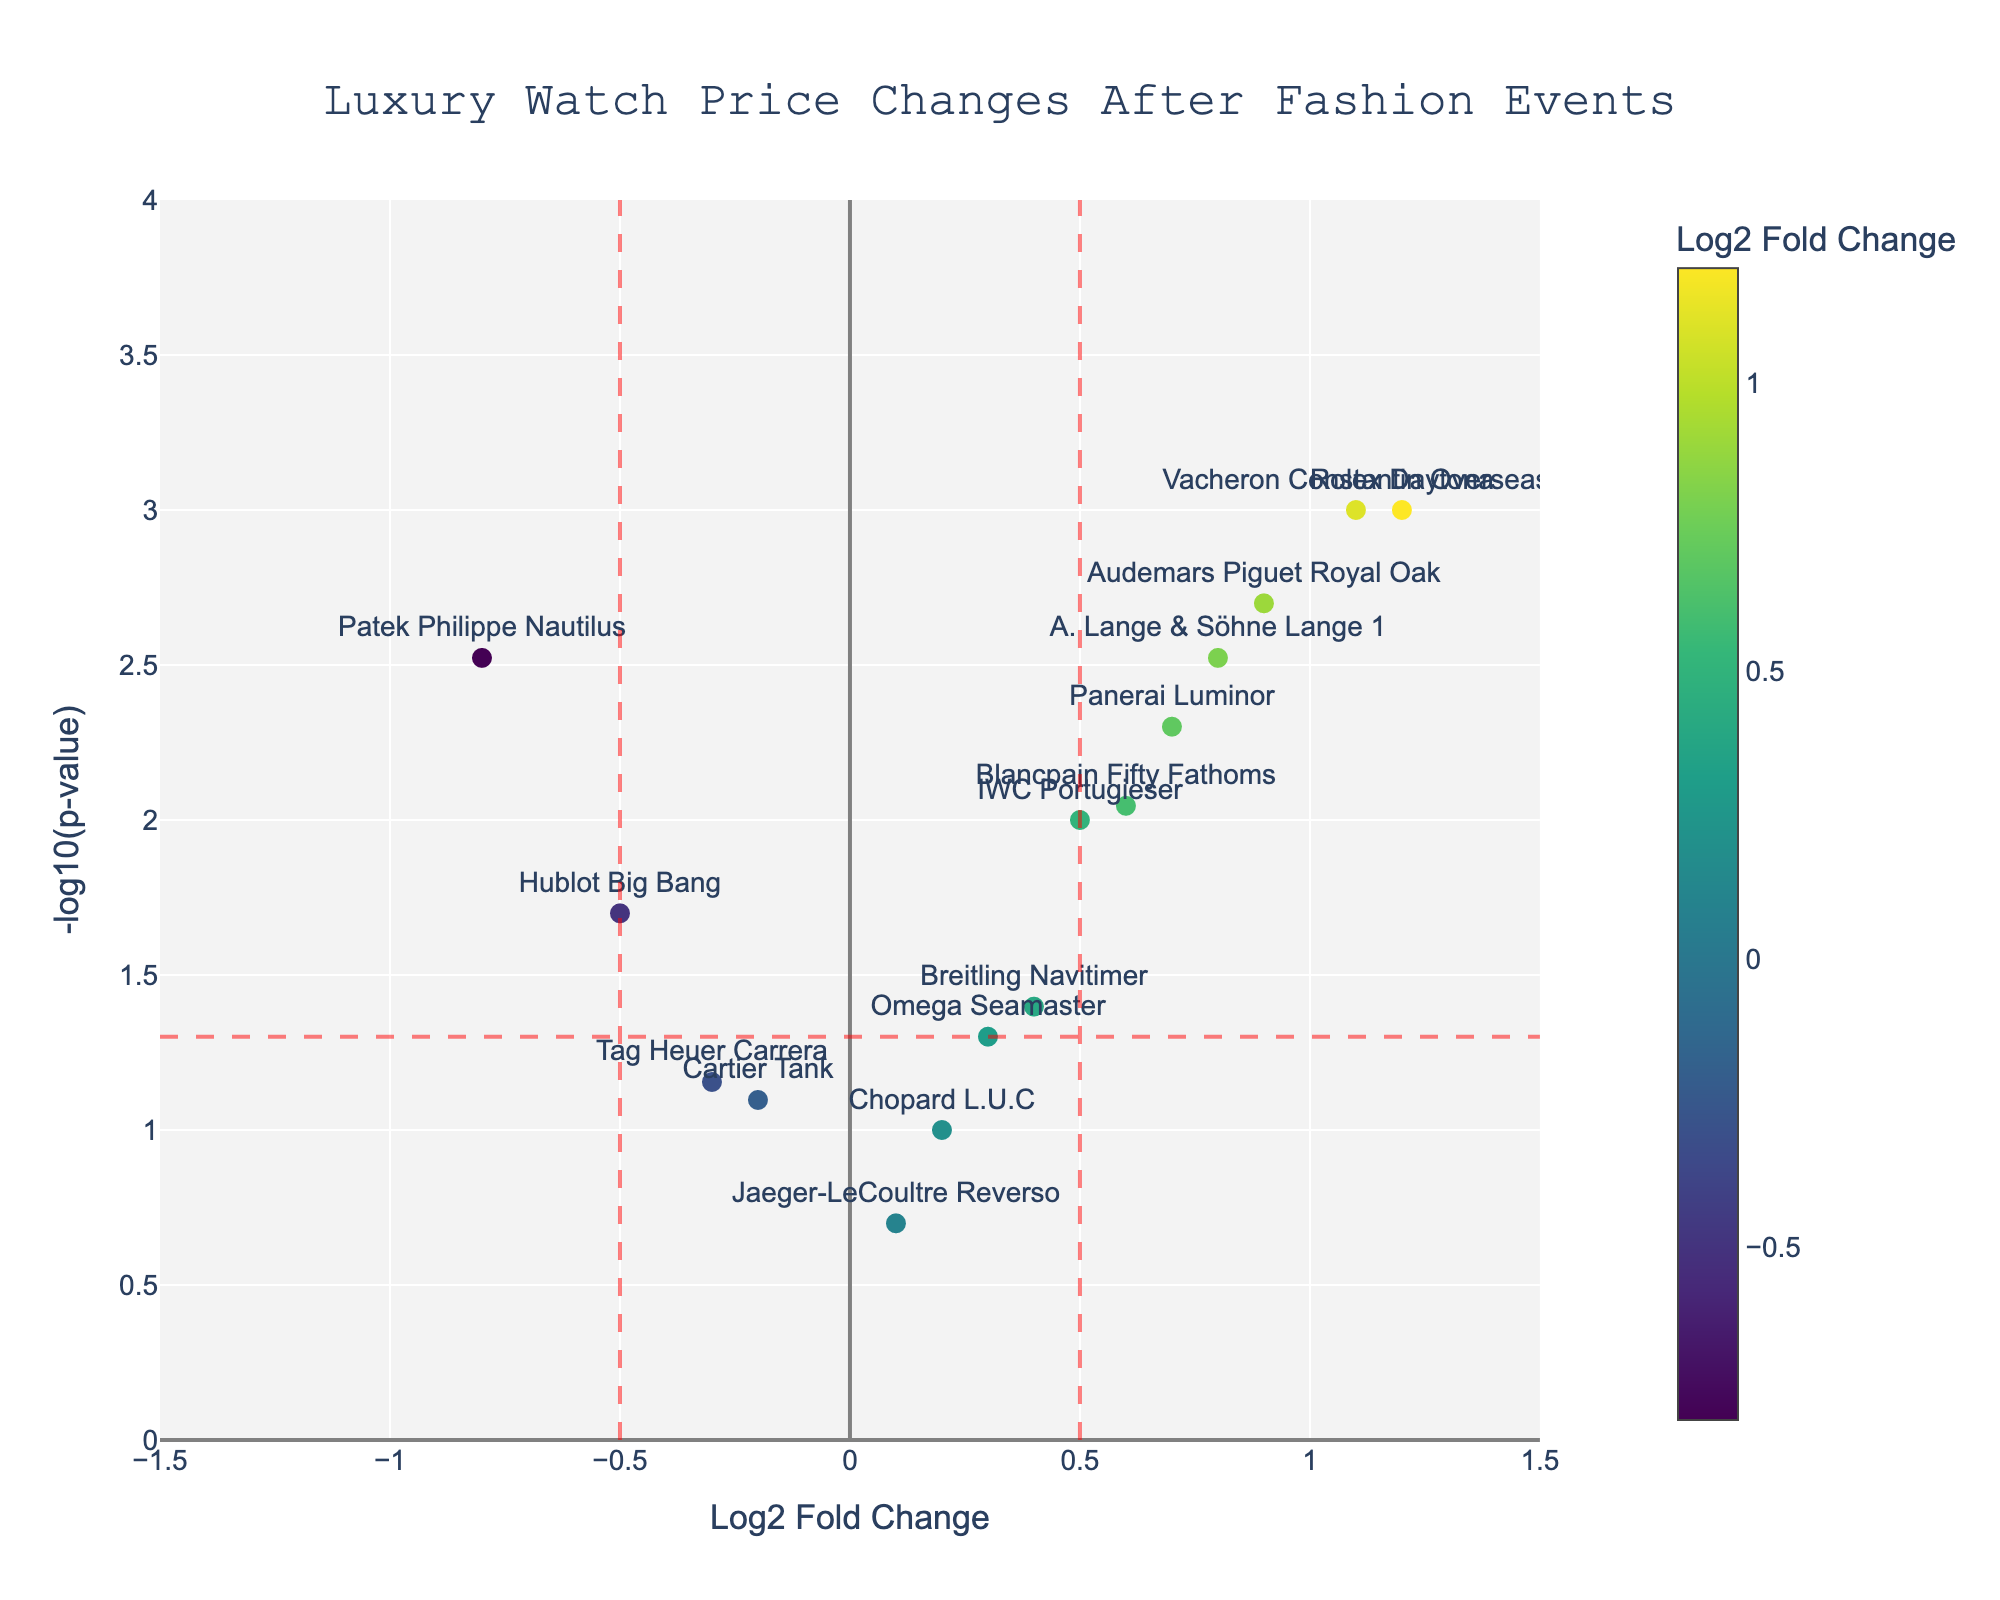How many watch models are displayed in the plot? The plot shows markers representing watch models each labeled with their names. Count each unique label or marker in the plot.
Answer: 15 What is the title of the plot? The title is typically placed at the top center of the plot. It usually briefly describes what the plot represents.
Answer: Luxury Watch Price Changes After Fashion Events Which watch model has the highest -log10(p-value)? Look for the marker that is positioned the highest on the y-axis, and check its label or hover text.
Answer: Rolex Daytona Are there any watch models with a log2 fold change greater than 1? If so, name them. Identify markers to the right of the vertical line at log2 fold change = 1, and read their labels or hover text.
Answer: Rolex Daytona, Vacheron Constantin Overseas Which watch model has the smallest p-value, and what is its log2 fold change? The smallest p-value corresponds to the highest point on the y-axis (-log10(p-value)). Locate the highest point, then check its log2 fold change via label or hover text.
Answer: Rolex Daytona, 1.2 How many watch models have a significant p-value (less than 0.05) and a positive log2 fold change? Locate markers above the horizontal red line at -log10(p-value) = 1.3 and to the right of the origin (x > 0). Count these markers.
Answer: 7 Which watch model has improved the most in market demand after the events? Market demand improvement is indicated by the highest positive log2 fold change combined with significant p-value. Check the highest fold change among models with significant p-values (p<0.05).
Answer: Rolex Daytona Compare the log2 fold changes between the Rolex Daytona and the Hublot Big Bang. Which one has increased more? Look at the x-axis position of both markers. Determine which marker lies more to the right.
Answer: Rolex Daytona Out of the models with a log2 fold change between -0.5 and 0.5, which one has the least significant p-value? Identify markers within the range -0.5 < log2 fold change < 0.5, then find the one closest to the x-axis (smallest value on the y-axis).
Answer: Jaeger-LeCoultre Reverso Which watch models show a decrease in price after the events but are not significant (p-value > 0.05)? Identify markers to the left of the origin (negative log2 fold change) and below the horizontal red line (p-value > 0.05).
Answer: Cartier Tank, Tag Heuer Carrera 